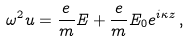Convert formula to latex. <formula><loc_0><loc_0><loc_500><loc_500>\omega ^ { 2 } u = \frac { e } { m } E + \frac { e } { m } E _ { 0 } e ^ { i \kappa z } \, ,</formula> 